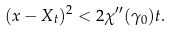<formula> <loc_0><loc_0><loc_500><loc_500>( x - X _ { t } ) ^ { 2 } < 2 \chi ^ { \prime \prime } ( \gamma _ { 0 } ) t .</formula> 